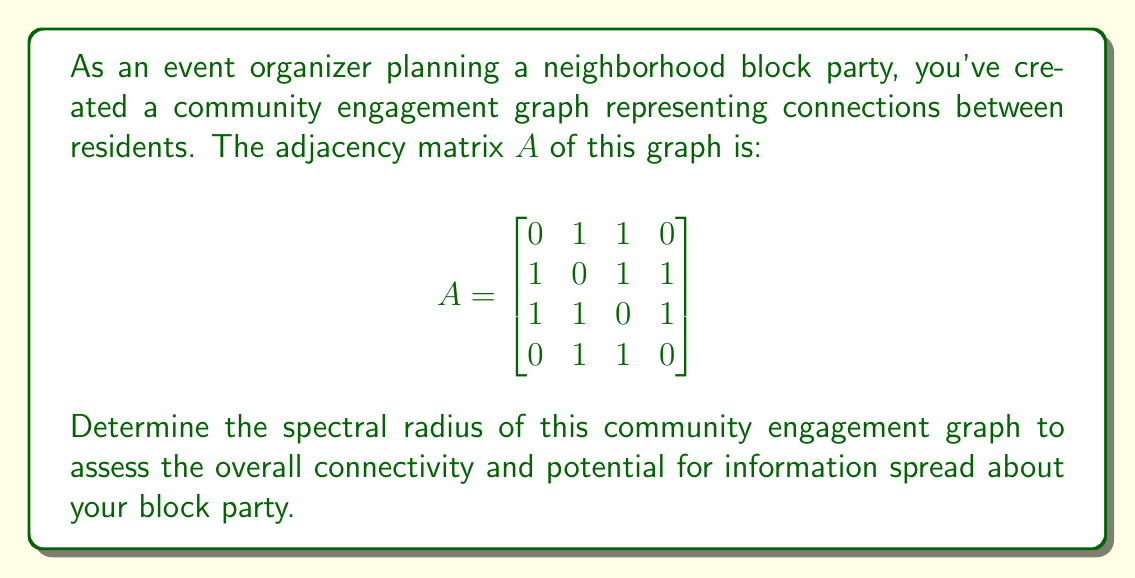Provide a solution to this math problem. To find the spectral radius of the community engagement graph, we need to follow these steps:

1) The spectral radius is the largest absolute eigenvalue of the adjacency matrix $A$.

2) To find the eigenvalues, we need to solve the characteristic equation:
   $\det(A - \lambda I) = 0$

3) Expanding this determinant:
   $$\begin{vmatrix}
   -\lambda & 1 & 1 & 0 \\
   1 & -\lambda & 1 & 1 \\
   1 & 1 & -\lambda & 1 \\
   0 & 1 & 1 & -\lambda
   \end{vmatrix} = 0$$

4) Calculating this determinant:
   $\lambda^4 - 3\lambda^2 - 2\lambda - 1 = 0$

5) This is a 4th degree polynomial equation. While it can be solved algebraically, it's complex. Using numerical methods or a computer algebra system, we find the roots are approximately:
   $\lambda_1 \approx 2.1701$
   $\lambda_2 \approx -1.7321$
   $\lambda_3 \approx 0.5620$
   $\lambda_4 \approx -1.0000$

6) The spectral radius is the largest absolute value among these eigenvalues, which is $|\lambda_1| \approx 2.1701$.

Therefore, the spectral radius of the community engagement graph is approximately 2.1701.
Answer: $2.1701$ 